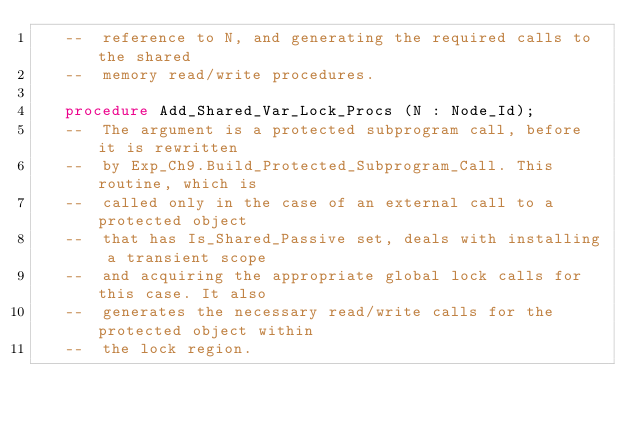Convert code to text. <code><loc_0><loc_0><loc_500><loc_500><_Ada_>   --  reference to N, and generating the required calls to the shared
   --  memory read/write procedures.

   procedure Add_Shared_Var_Lock_Procs (N : Node_Id);
   --  The argument is a protected subprogram call, before it is rewritten
   --  by Exp_Ch9.Build_Protected_Subprogram_Call. This routine, which is
   --  called only in the case of an external call to a protected object
   --  that has Is_Shared_Passive set, deals with installing a transient scope
   --  and acquiring the appropriate global lock calls for this case. It also
   --  generates the necessary read/write calls for the protected object within
   --  the lock region.
</code> 